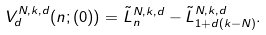Convert formula to latex. <formula><loc_0><loc_0><loc_500><loc_500>V _ { d } ^ { N , k , d } ( n ; ( 0 ) ) = \tilde { L } _ { n } ^ { N , k , d } - \tilde { L } _ { 1 + d ( k - N ) } ^ { N , k , d } .</formula> 